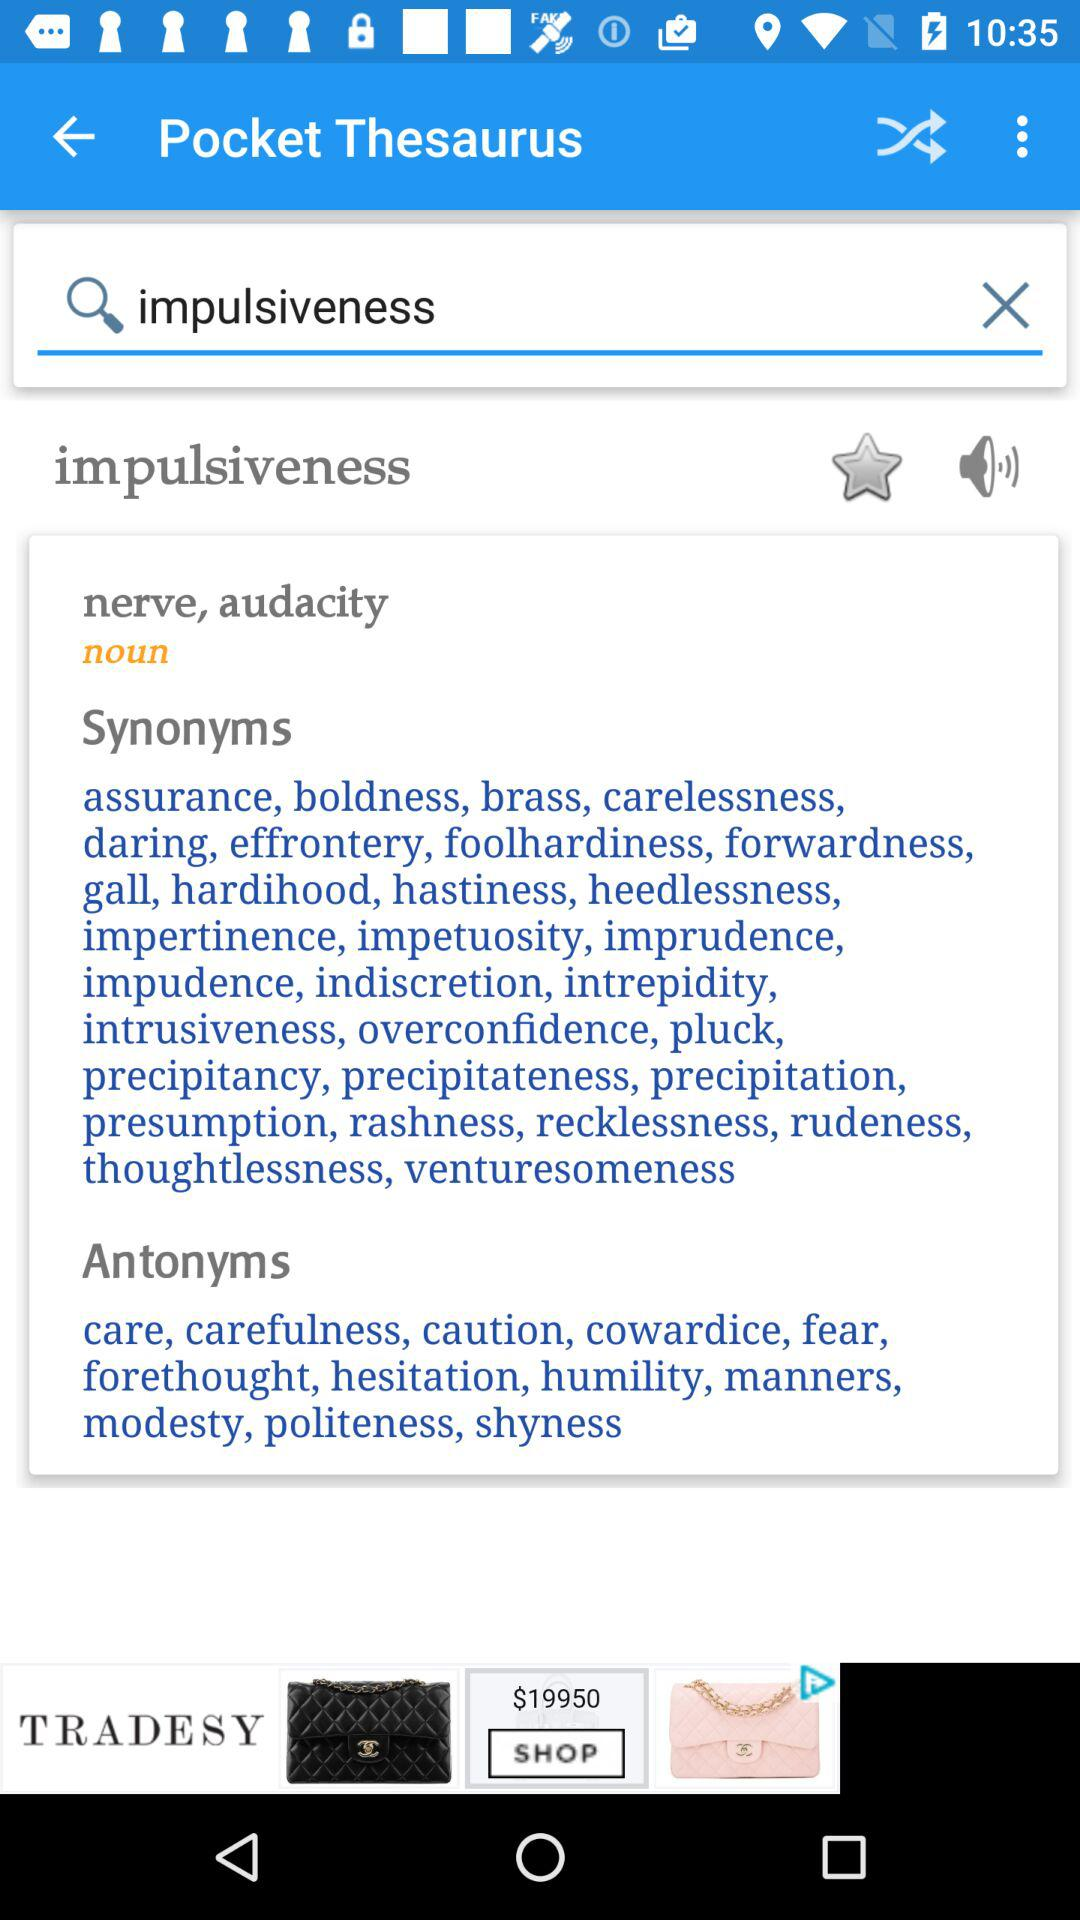Which text is entered in the input field? The entered text is "impulsiveness". 